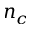Convert formula to latex. <formula><loc_0><loc_0><loc_500><loc_500>n _ { c }</formula> 